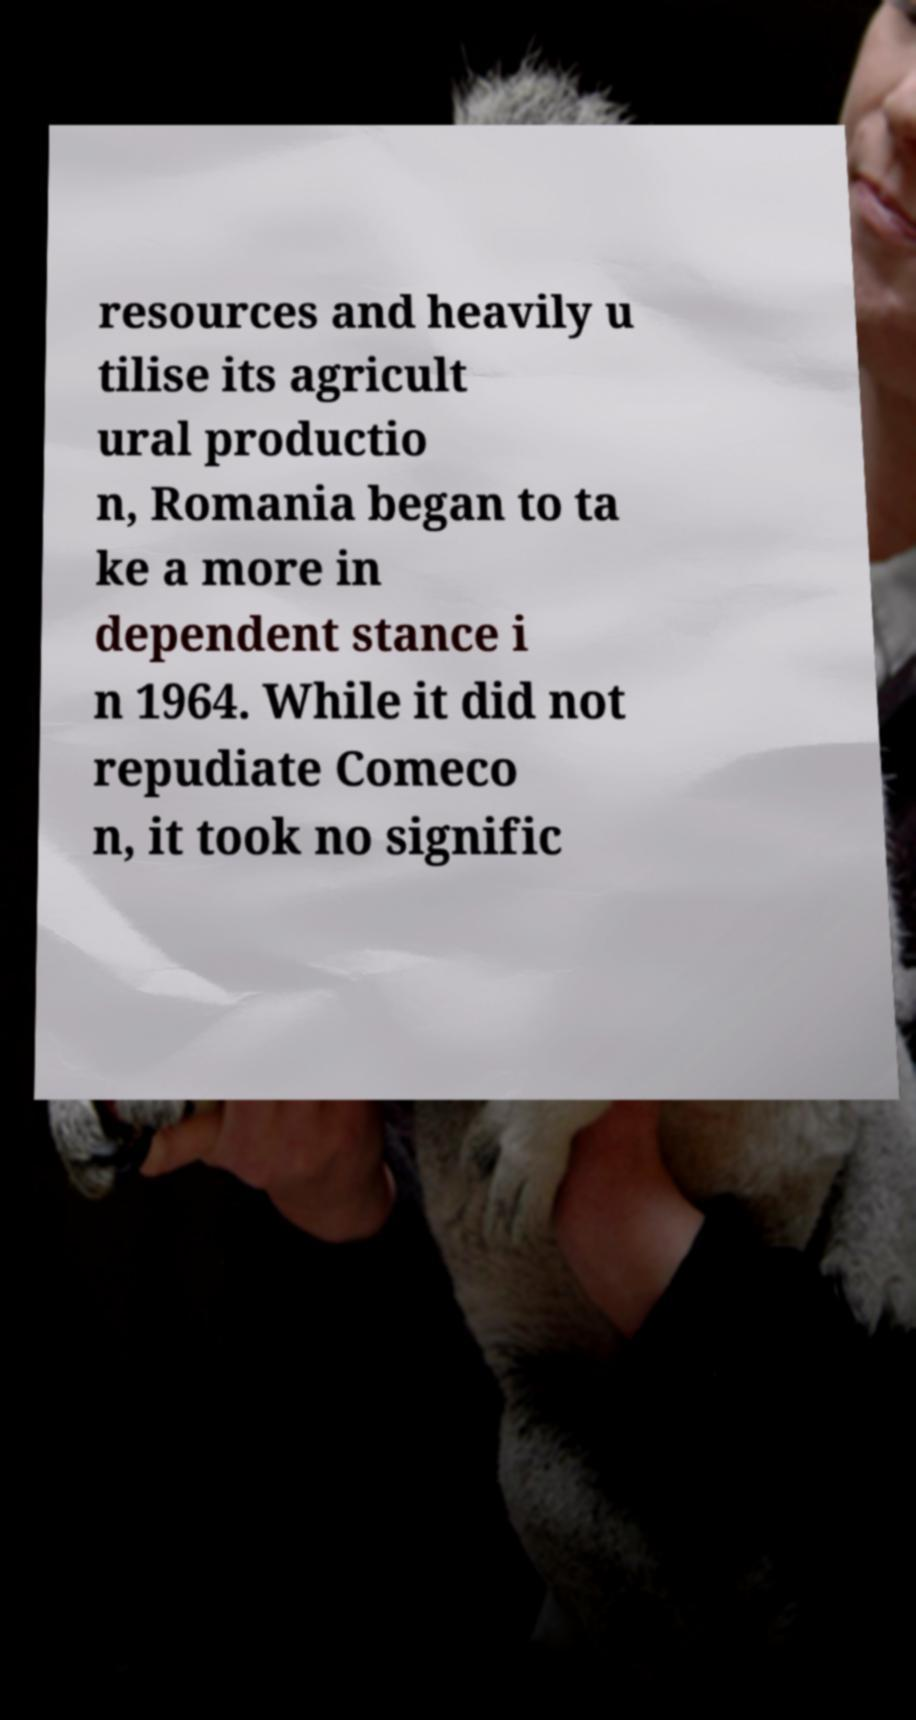Could you assist in decoding the text presented in this image and type it out clearly? resources and heavily u tilise its agricult ural productio n, Romania began to ta ke a more in dependent stance i n 1964. While it did not repudiate Comeco n, it took no signific 